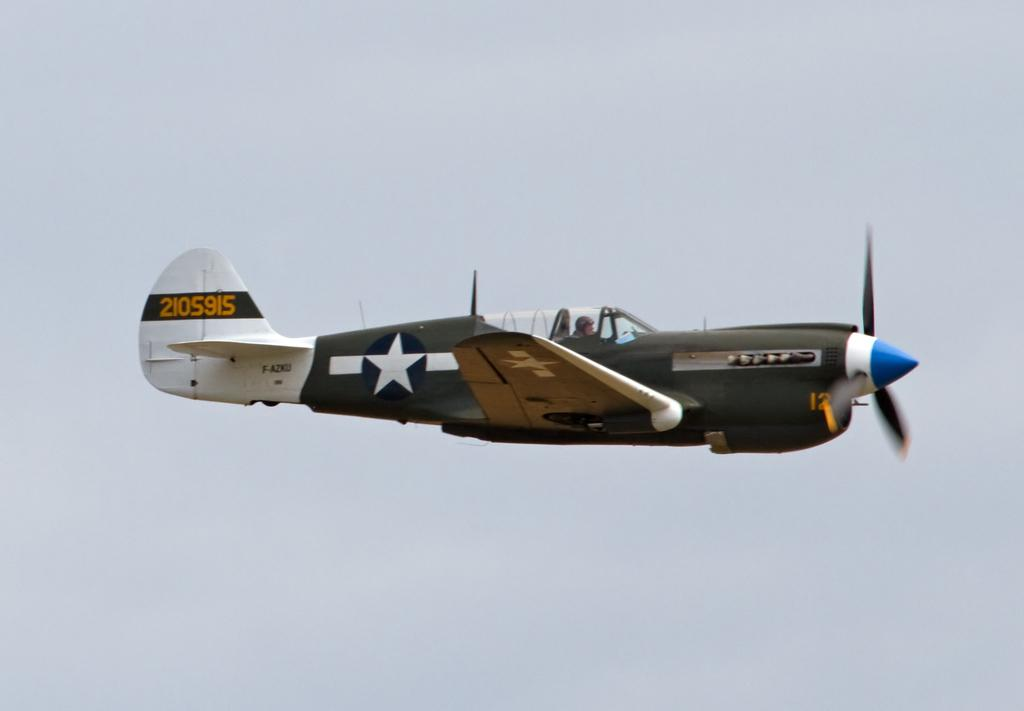What is the main subject of the image? The main subject of the image is an aircraft. What is the aircraft doing in the image? The aircraft is flying in the air. What can be seen in the background of the image? The sky is visible in the background of the image. What type of plastic is covering the aircraft in the image? There is no plastic covering the aircraft in the image; it is flying in the air without any visible covering. 